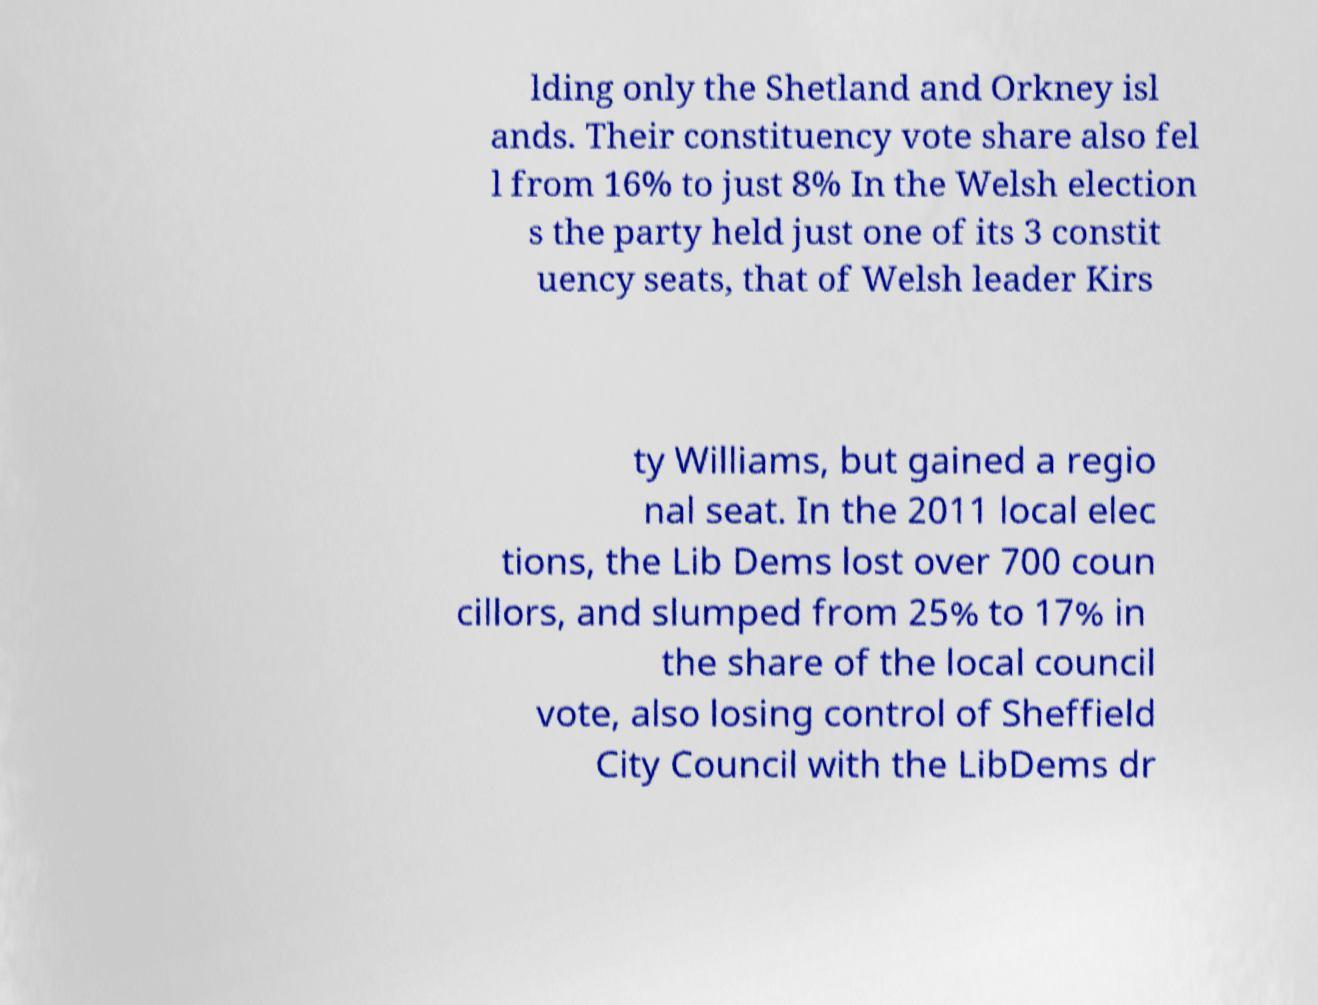Please read and relay the text visible in this image. What does it say? lding only the Shetland and Orkney isl ands. Their constituency vote share also fel l from 16% to just 8% In the Welsh election s the party held just one of its 3 constit uency seats, that of Welsh leader Kirs ty Williams, but gained a regio nal seat. In the 2011 local elec tions, the Lib Dems lost over 700 coun cillors, and slumped from 25% to 17% in the share of the local council vote, also losing control of Sheffield City Council with the LibDems dr 